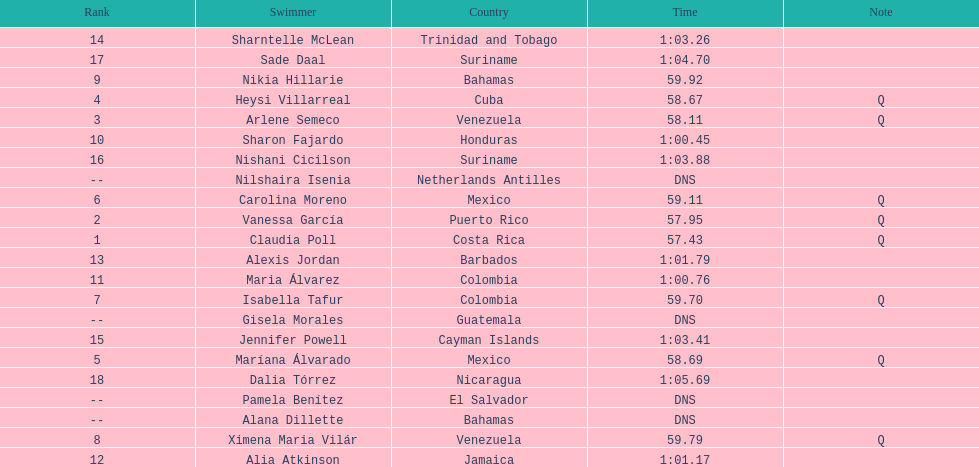What swimmer had the top or first rank? Claudia Poll. 